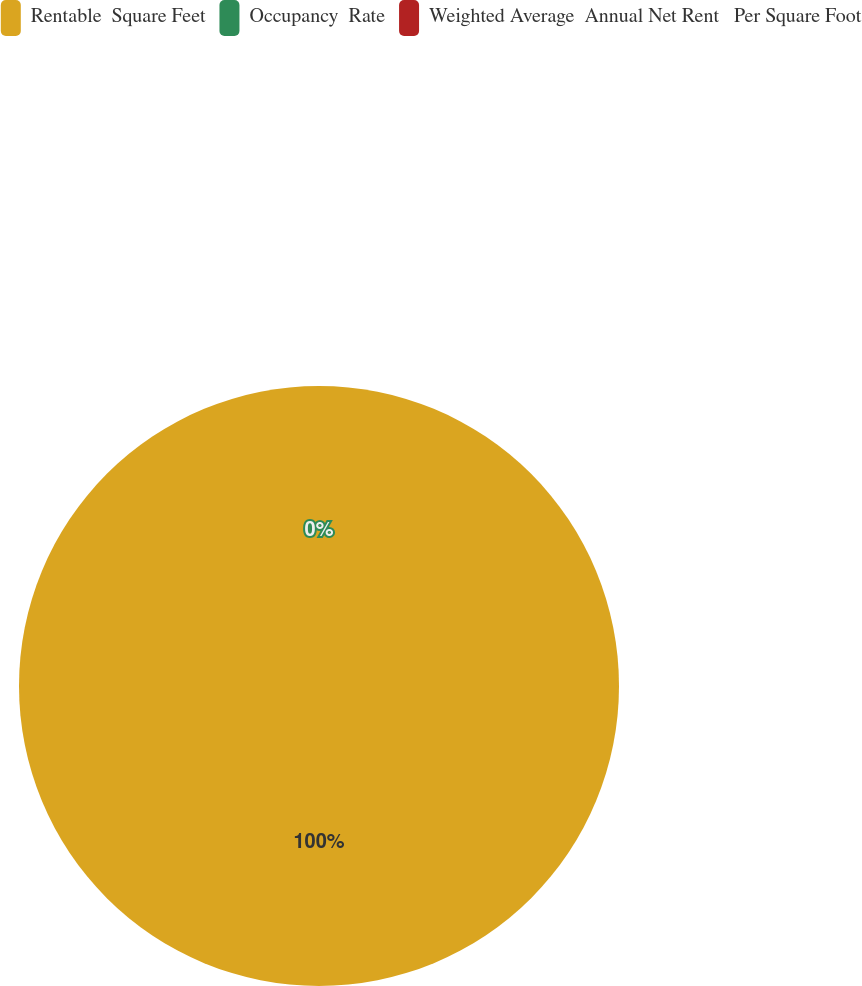<chart> <loc_0><loc_0><loc_500><loc_500><pie_chart><fcel>Rentable  Square Feet<fcel>Occupancy  Rate<fcel>Weighted Average  Annual Net Rent   Per Square Foot<nl><fcel>100.0%<fcel>0.0%<fcel>0.0%<nl></chart> 